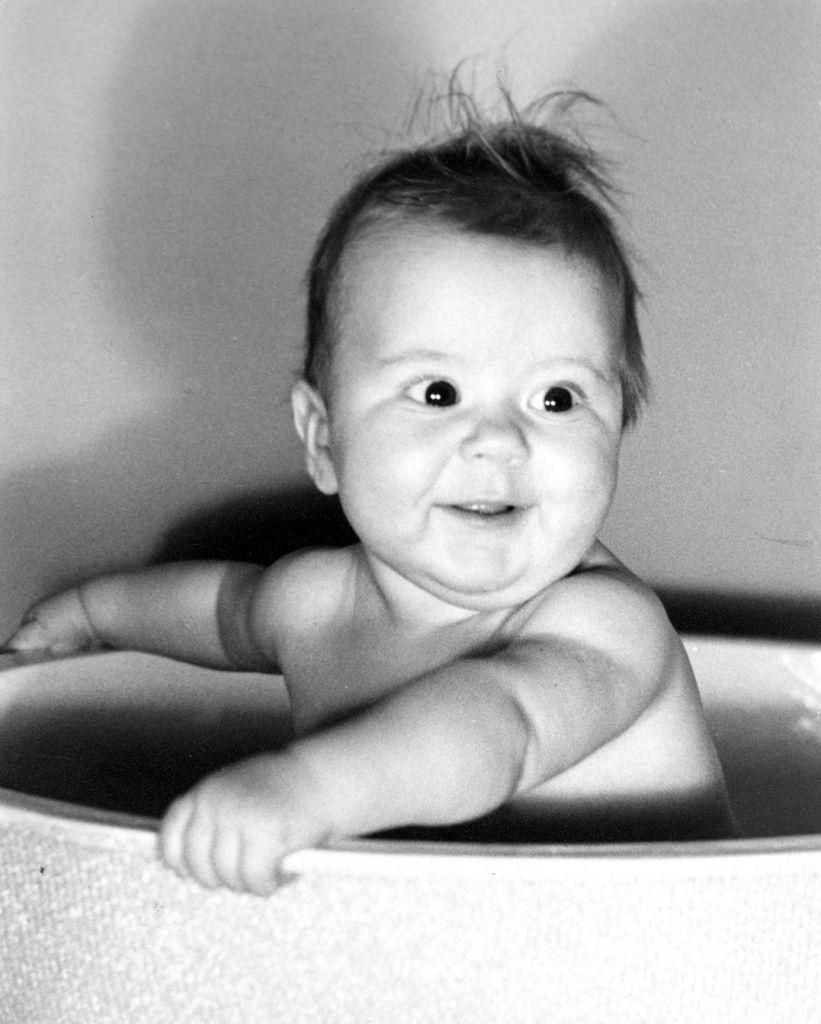What is the person in the image doing? The person is sitting in the tub. What can be seen in the background of the image? The background of the image includes a wall. What is the color scheme of the image? The image is black and white. Can you see any fairies playing on the playground in the image? There is no playground or fairies present in the image; it features a person sitting in a tub with a black and white color scheme and a wall in the background. 